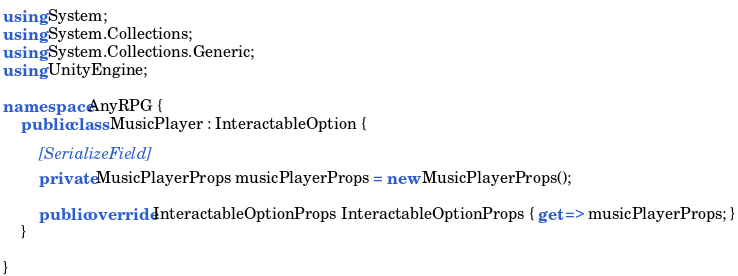Convert code to text. <code><loc_0><loc_0><loc_500><loc_500><_C#_>using System;
using System.Collections;
using System.Collections.Generic;
using UnityEngine;

namespace AnyRPG {
    public class MusicPlayer : InteractableOption {

        [SerializeField]
        private MusicPlayerProps musicPlayerProps = new MusicPlayerProps();

        public override InteractableOptionProps InteractableOptionProps { get => musicPlayerProps; }
    }

}</code> 